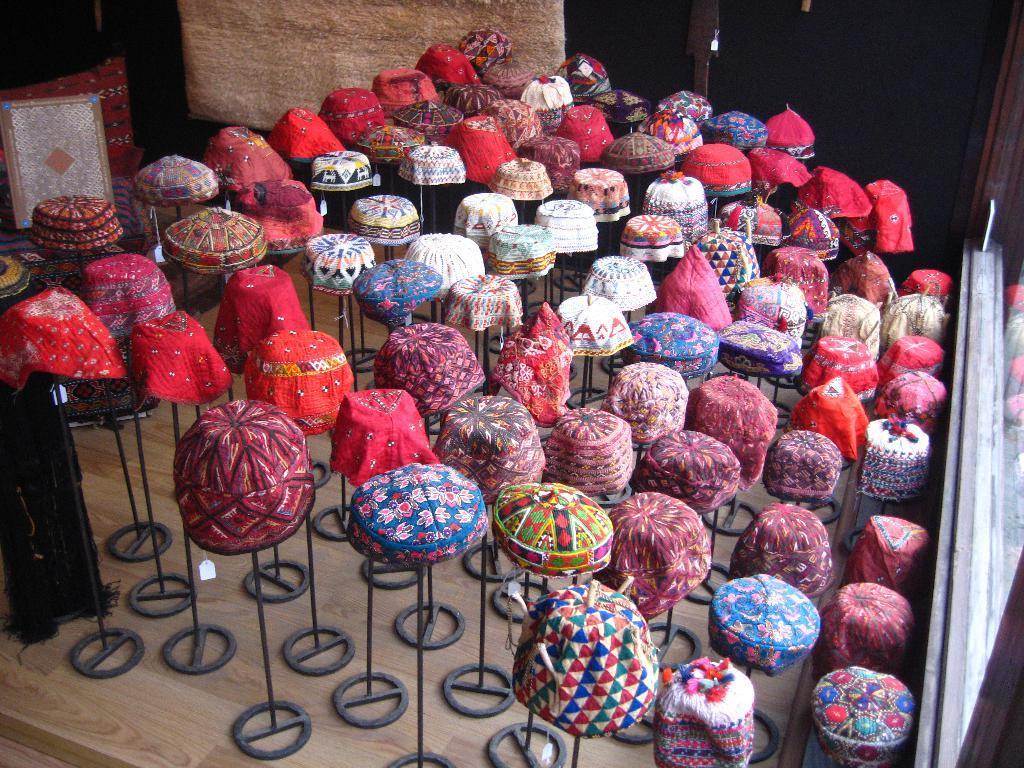Can you describe this image briefly? In this image, we can see many caps on the stands and in the background, there is a board, wall and we can see a window and there is a cloth which is in black color and we can see a table. At the bottom, there is table. 